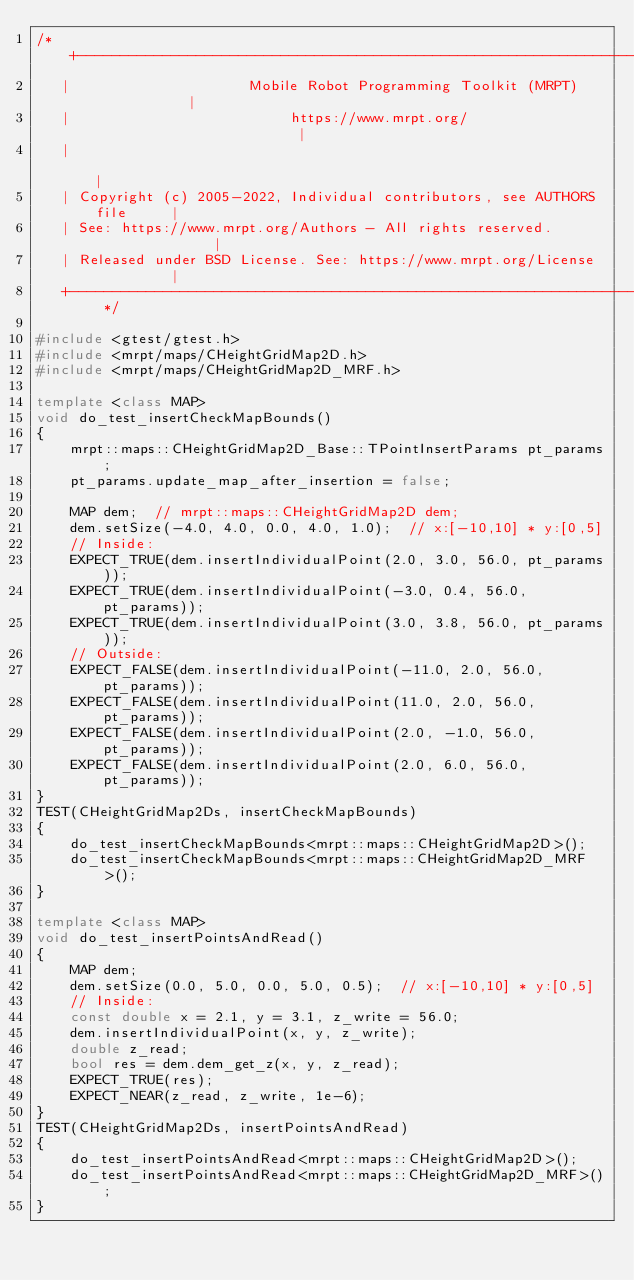<code> <loc_0><loc_0><loc_500><loc_500><_C++_>/* +------------------------------------------------------------------------+
   |                     Mobile Robot Programming Toolkit (MRPT)            |
   |                          https://www.mrpt.org/                         |
   |                                                                        |
   | Copyright (c) 2005-2022, Individual contributors, see AUTHORS file     |
   | See: https://www.mrpt.org/Authors - All rights reserved.               |
   | Released under BSD License. See: https://www.mrpt.org/License          |
   +------------------------------------------------------------------------+ */

#include <gtest/gtest.h>
#include <mrpt/maps/CHeightGridMap2D.h>
#include <mrpt/maps/CHeightGridMap2D_MRF.h>

template <class MAP>
void do_test_insertCheckMapBounds()
{
	mrpt::maps::CHeightGridMap2D_Base::TPointInsertParams pt_params;
	pt_params.update_map_after_insertion = false;

	MAP dem;  // mrpt::maps::CHeightGridMap2D dem;
	dem.setSize(-4.0, 4.0, 0.0, 4.0, 1.0);	// x:[-10,10] * y:[0,5]
	// Inside:
	EXPECT_TRUE(dem.insertIndividualPoint(2.0, 3.0, 56.0, pt_params));
	EXPECT_TRUE(dem.insertIndividualPoint(-3.0, 0.4, 56.0, pt_params));
	EXPECT_TRUE(dem.insertIndividualPoint(3.0, 3.8, 56.0, pt_params));
	// Outside:
	EXPECT_FALSE(dem.insertIndividualPoint(-11.0, 2.0, 56.0, pt_params));
	EXPECT_FALSE(dem.insertIndividualPoint(11.0, 2.0, 56.0, pt_params));
	EXPECT_FALSE(dem.insertIndividualPoint(2.0, -1.0, 56.0, pt_params));
	EXPECT_FALSE(dem.insertIndividualPoint(2.0, 6.0, 56.0, pt_params));
}
TEST(CHeightGridMap2Ds, insertCheckMapBounds)
{
	do_test_insertCheckMapBounds<mrpt::maps::CHeightGridMap2D>();
	do_test_insertCheckMapBounds<mrpt::maps::CHeightGridMap2D_MRF>();
}

template <class MAP>
void do_test_insertPointsAndRead()
{
	MAP dem;
	dem.setSize(0.0, 5.0, 0.0, 5.0, 0.5);  // x:[-10,10] * y:[0,5]
	// Inside:
	const double x = 2.1, y = 3.1, z_write = 56.0;
	dem.insertIndividualPoint(x, y, z_write);
	double z_read;
	bool res = dem.dem_get_z(x, y, z_read);
	EXPECT_TRUE(res);
	EXPECT_NEAR(z_read, z_write, 1e-6);
}
TEST(CHeightGridMap2Ds, insertPointsAndRead)
{
	do_test_insertPointsAndRead<mrpt::maps::CHeightGridMap2D>();
	do_test_insertPointsAndRead<mrpt::maps::CHeightGridMap2D_MRF>();
}
</code> 